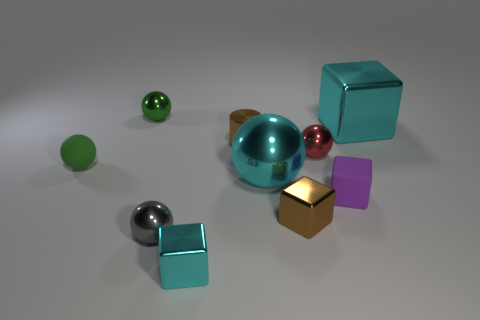What material is the big ball?
Provide a succinct answer. Metal. The cylinder has what color?
Give a very brief answer. Brown. There is a cube that is both to the right of the red metallic ball and in front of the cyan ball; what is its color?
Your answer should be very brief. Purple. Is there anything else that has the same material as the tiny gray thing?
Give a very brief answer. Yes. Are the small brown cylinder and the green thing behind the large cyan block made of the same material?
Make the answer very short. Yes. How big is the cyan cube that is in front of the metallic cube on the right side of the purple matte cube?
Provide a short and direct response. Small. Is there anything else that has the same color as the small rubber ball?
Offer a terse response. Yes. Does the cyan block in front of the tiny brown cube have the same material as the tiny green sphere that is on the left side of the green shiny ball?
Ensure brevity in your answer.  No. There is a tiny sphere that is both on the left side of the tiny gray metal sphere and to the right of the tiny green matte object; what is its material?
Offer a very short reply. Metal. There is a red metal object; does it have the same shape as the cyan metal thing that is on the right side of the purple block?
Provide a succinct answer. No. 